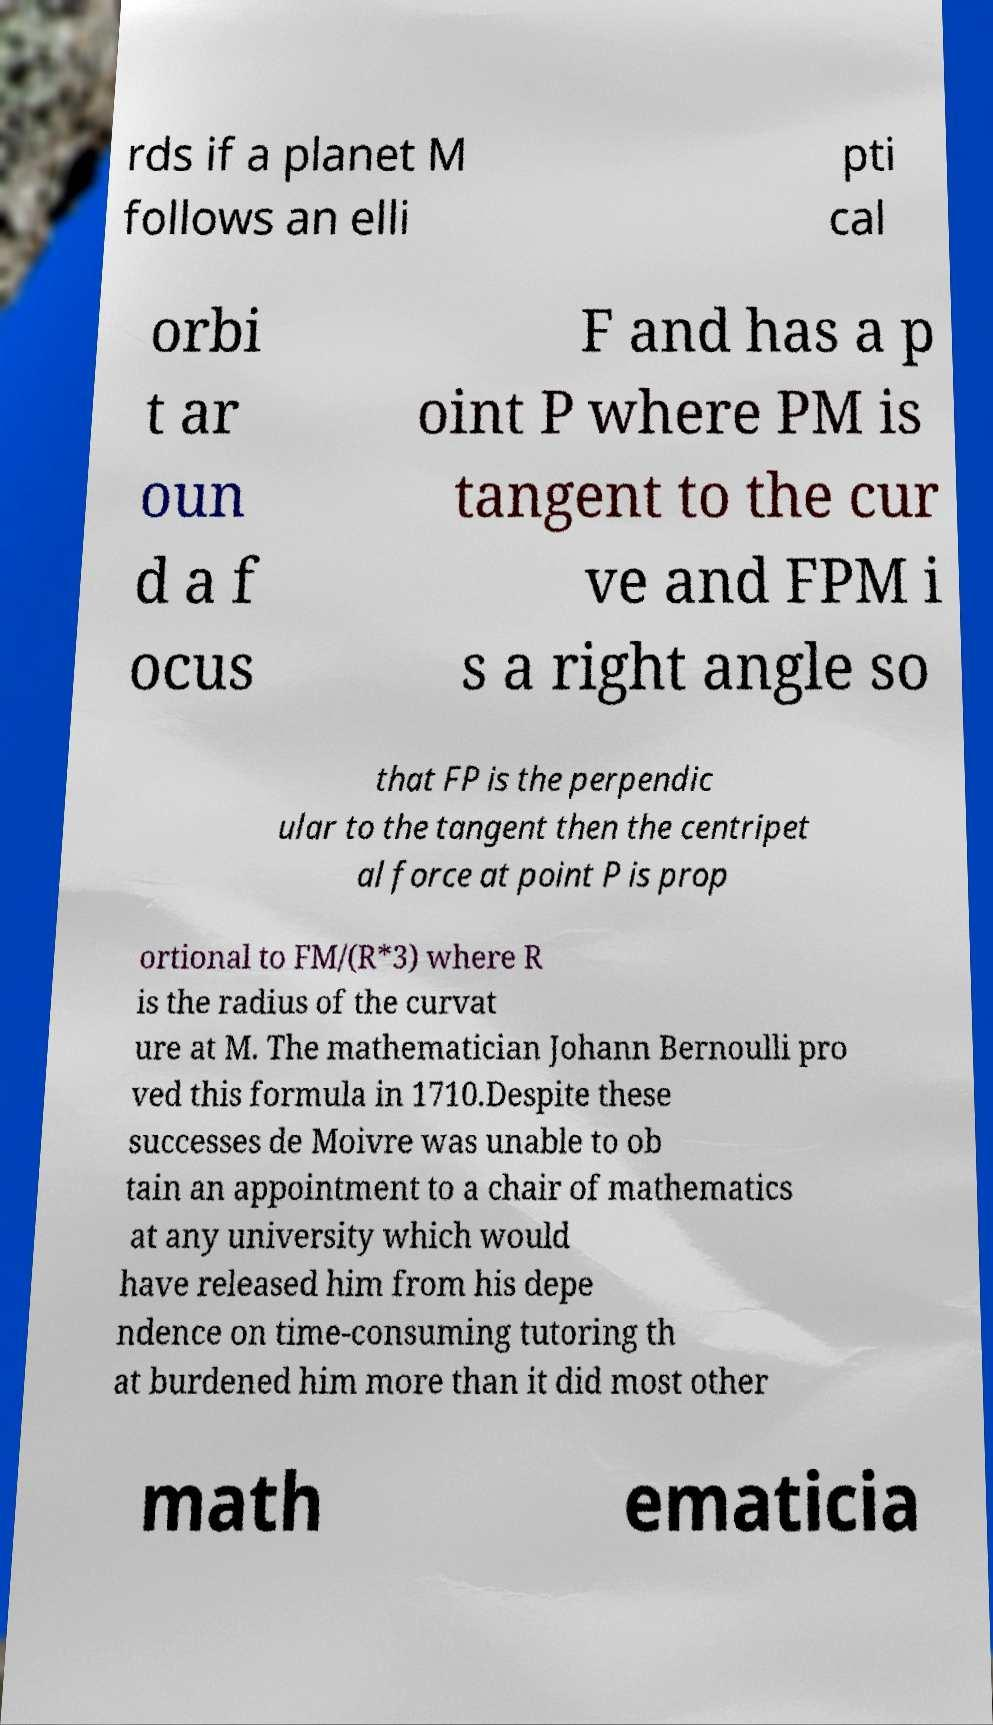Could you extract and type out the text from this image? rds if a planet M follows an elli pti cal orbi t ar oun d a f ocus F and has a p oint P where PM is tangent to the cur ve and FPM i s a right angle so that FP is the perpendic ular to the tangent then the centripet al force at point P is prop ortional to FM/(R*3) where R is the radius of the curvat ure at M. The mathematician Johann Bernoulli pro ved this formula in 1710.Despite these successes de Moivre was unable to ob tain an appointment to a chair of mathematics at any university which would have released him from his depe ndence on time-consuming tutoring th at burdened him more than it did most other math ematicia 